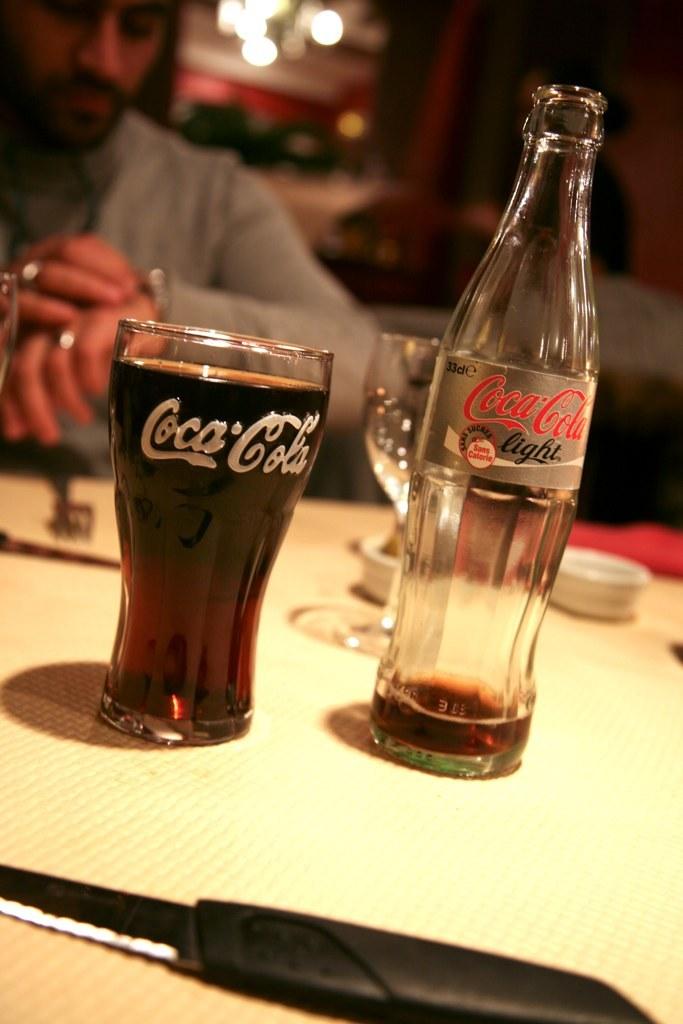Which side is the coke glass on?
Give a very brief answer. Left. What brand is the empty bottle?
Offer a very short reply. Coca-cola. 